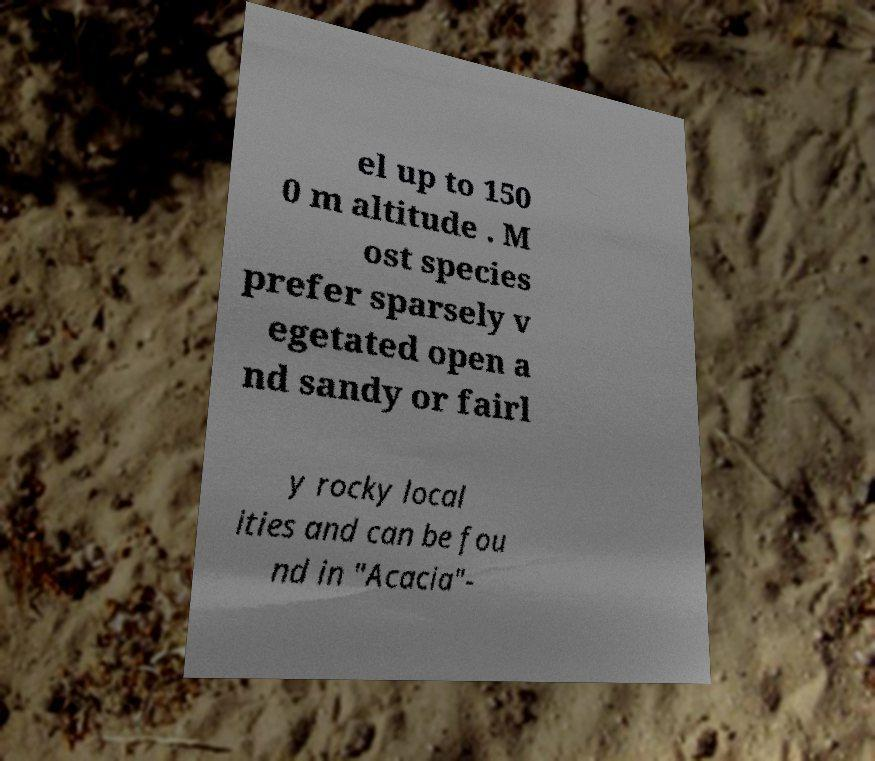Could you extract and type out the text from this image? el up to 150 0 m altitude . M ost species prefer sparsely v egetated open a nd sandy or fairl y rocky local ities and can be fou nd in "Acacia"- 